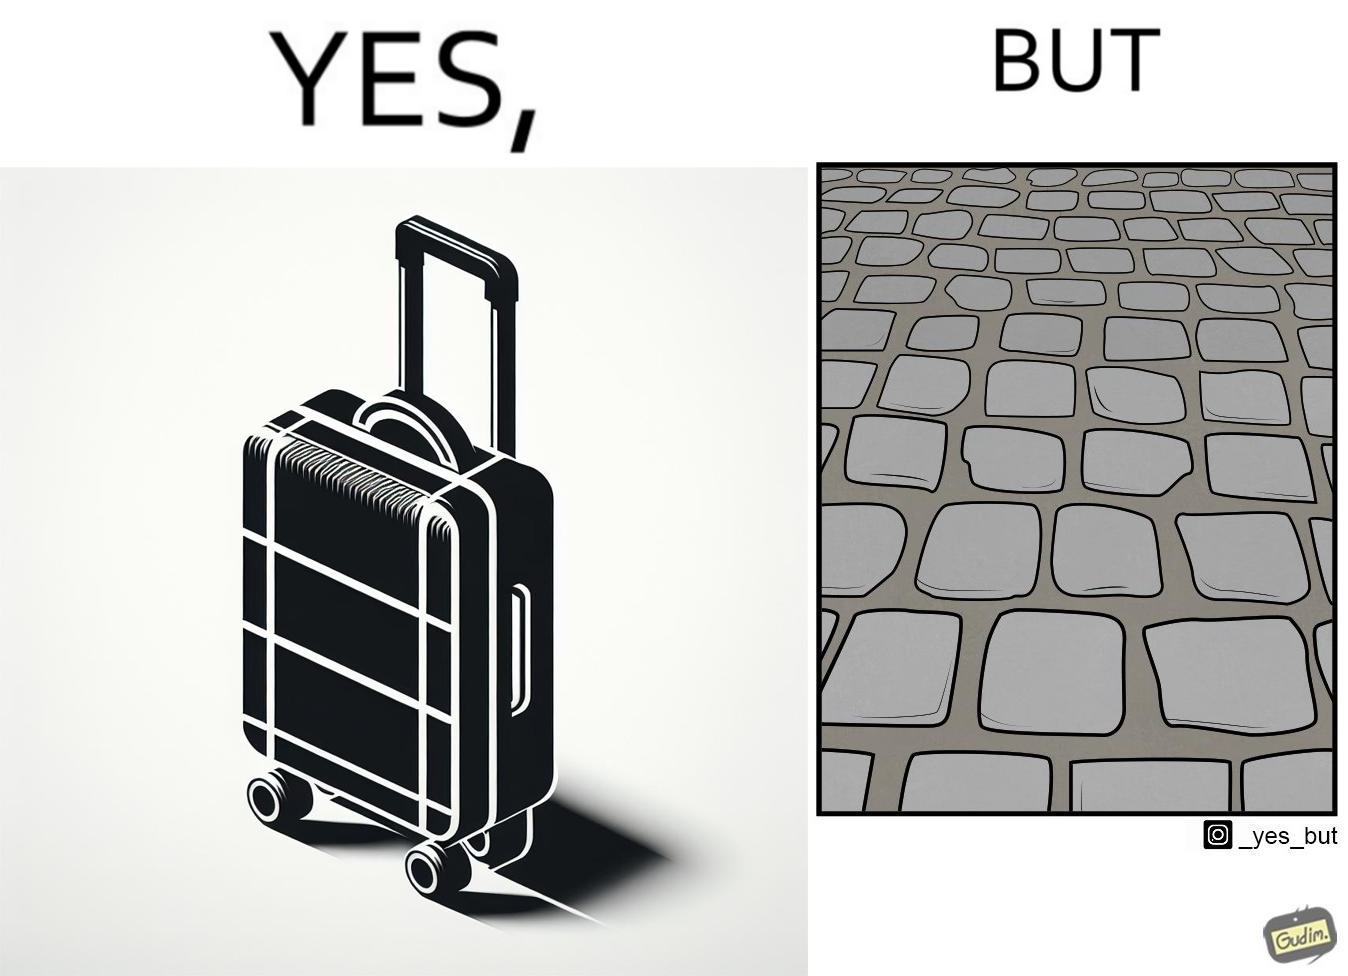Is this a satirical image? Yes, this image is satirical. 